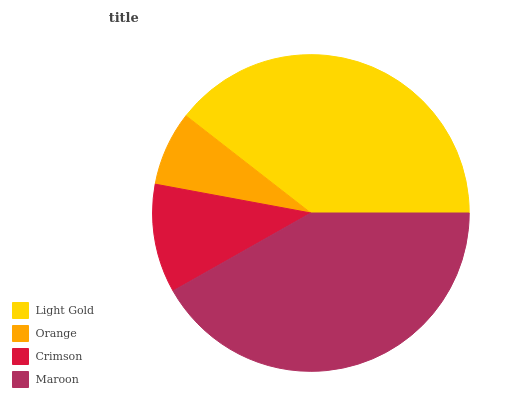Is Orange the minimum?
Answer yes or no. Yes. Is Maroon the maximum?
Answer yes or no. Yes. Is Crimson the minimum?
Answer yes or no. No. Is Crimson the maximum?
Answer yes or no. No. Is Crimson greater than Orange?
Answer yes or no. Yes. Is Orange less than Crimson?
Answer yes or no. Yes. Is Orange greater than Crimson?
Answer yes or no. No. Is Crimson less than Orange?
Answer yes or no. No. Is Light Gold the high median?
Answer yes or no. Yes. Is Crimson the low median?
Answer yes or no. Yes. Is Orange the high median?
Answer yes or no. No. Is Light Gold the low median?
Answer yes or no. No. 